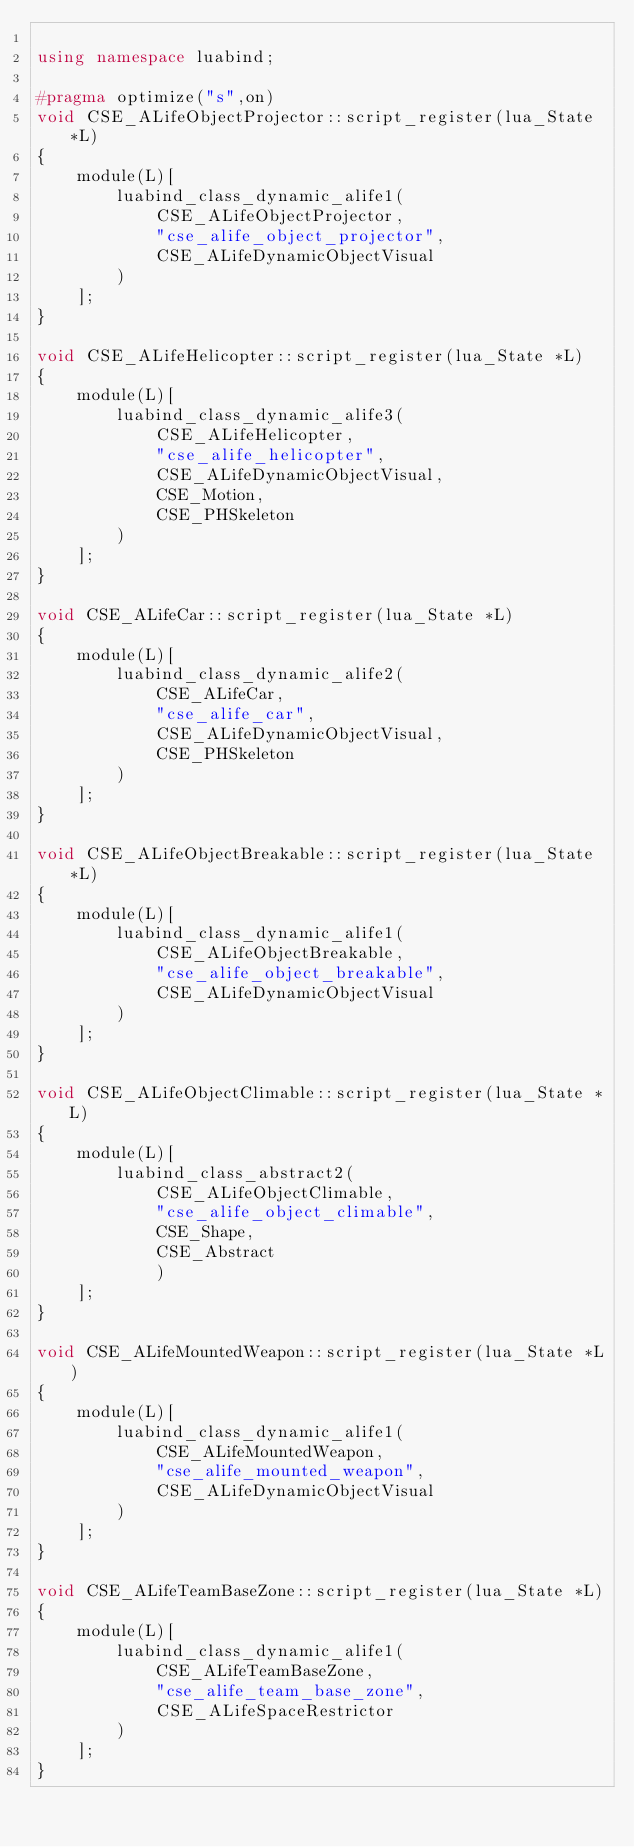<code> <loc_0><loc_0><loc_500><loc_500><_C++_>
using namespace luabind;

#pragma optimize("s",on)
void CSE_ALifeObjectProjector::script_register(lua_State *L)
{
	module(L)[
		luabind_class_dynamic_alife1(
			CSE_ALifeObjectProjector,
			"cse_alife_object_projector",
			CSE_ALifeDynamicObjectVisual
		)
	];
}

void CSE_ALifeHelicopter::script_register(lua_State *L)
{
	module(L)[
		luabind_class_dynamic_alife3(
			CSE_ALifeHelicopter,
			"cse_alife_helicopter",
			CSE_ALifeDynamicObjectVisual,
			CSE_Motion,
			CSE_PHSkeleton
		)
	];
}

void CSE_ALifeCar::script_register(lua_State *L)
{
	module(L)[
		luabind_class_dynamic_alife2(
			CSE_ALifeCar,
			"cse_alife_car",
			CSE_ALifeDynamicObjectVisual,
			CSE_PHSkeleton
		)
	];
}

void CSE_ALifeObjectBreakable::script_register(lua_State *L)
{
	module(L)[
		luabind_class_dynamic_alife1(
			CSE_ALifeObjectBreakable,
			"cse_alife_object_breakable",
			CSE_ALifeDynamicObjectVisual
		)
	];
}

void CSE_ALifeObjectClimable::script_register(lua_State *L)
{
	module(L)[
		luabind_class_abstract2(
			CSE_ALifeObjectClimable,
			"cse_alife_object_climable",
			CSE_Shape,
			CSE_Abstract
			)
	];
}

void CSE_ALifeMountedWeapon::script_register(lua_State *L)
{
	module(L)[
		luabind_class_dynamic_alife1(
			CSE_ALifeMountedWeapon,
			"cse_alife_mounted_weapon",
			CSE_ALifeDynamicObjectVisual
		)
	];
}

void CSE_ALifeTeamBaseZone::script_register(lua_State *L)
{
	module(L)[
		luabind_class_dynamic_alife1(
			CSE_ALifeTeamBaseZone,
			"cse_alife_team_base_zone",
			CSE_ALifeSpaceRestrictor
		)
	];
}

</code> 